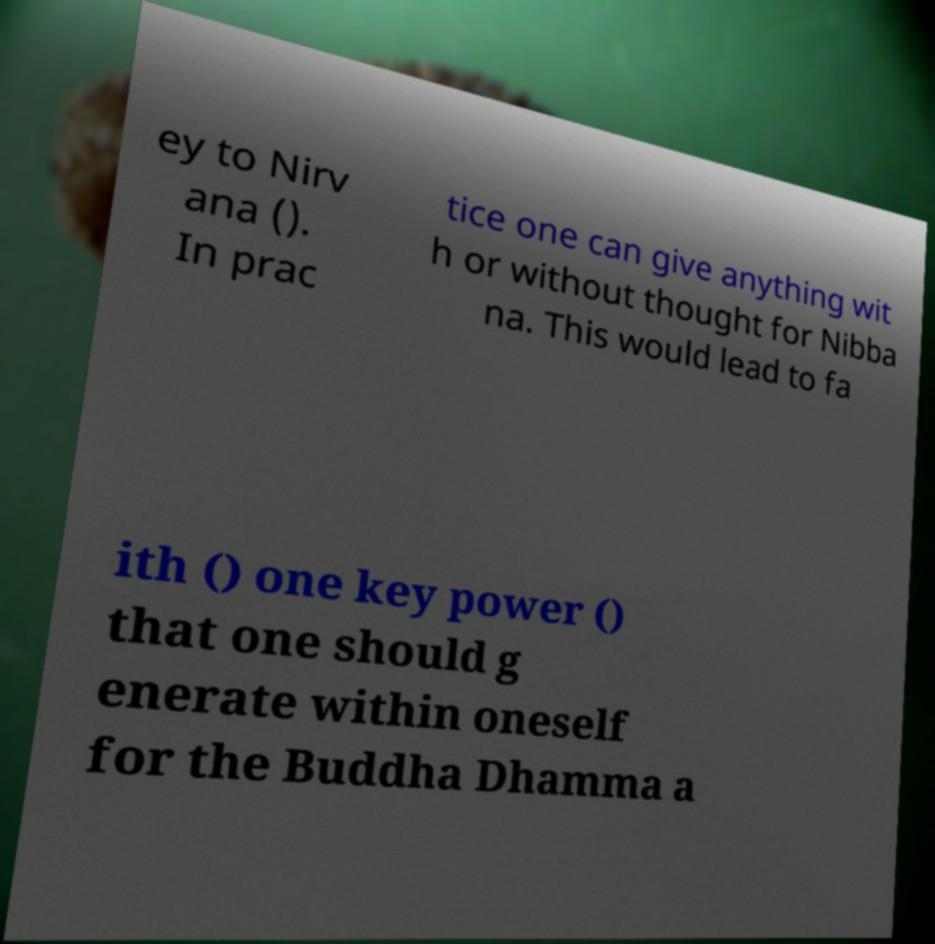Please read and relay the text visible in this image. What does it say? ey to Nirv ana (). In prac tice one can give anything wit h or without thought for Nibba na. This would lead to fa ith () one key power () that one should g enerate within oneself for the Buddha Dhamma a 